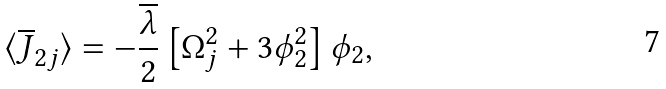Convert formula to latex. <formula><loc_0><loc_0><loc_500><loc_500>\langle \overline { J } _ { 2 j } \rangle = - \frac { \overline { \lambda } } { 2 } \left [ { \Omega } _ { j } ^ { 2 } + 3 { \phi } _ { 2 } ^ { 2 } \right ] { \phi } _ { 2 } ,</formula> 